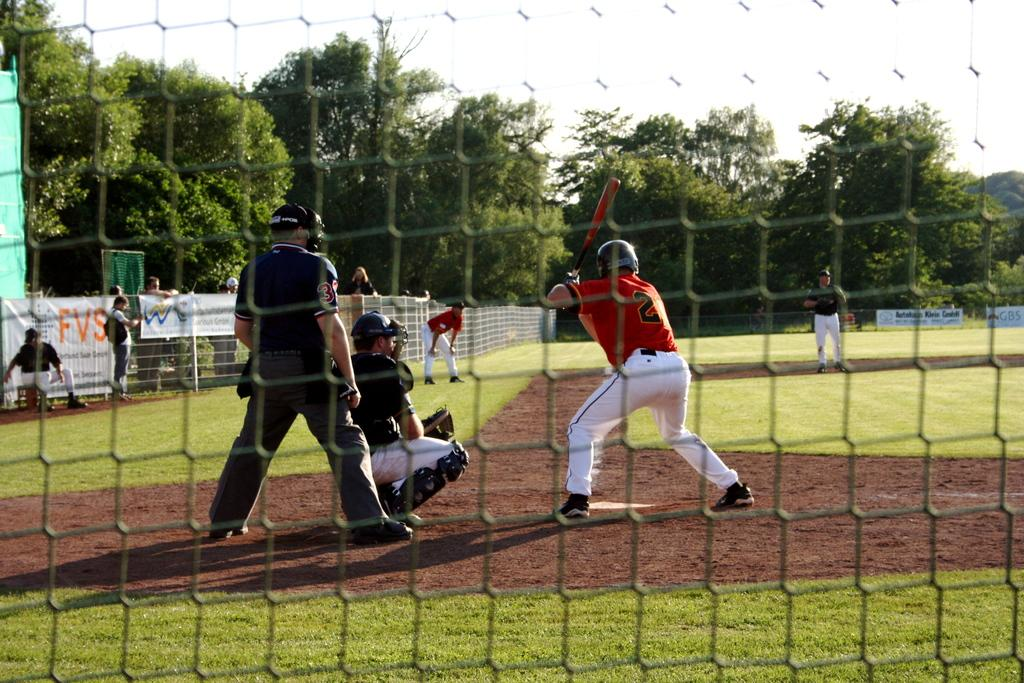What are the people in the image doing? There are people on the ground in the image, but their specific activity is not mentioned. What object is a person holding in the image? A person is holding a bat in the image. What can be seen on the fence in the image? There are banners on the fence in the image. What is visible in the background of the image? There are trees in the background of the image. What type of jam is being spread on the banners in the image? There is no jam present in the image; it features people on the ground, a person holding a bat, banners on the fence, and trees in the background. --- 